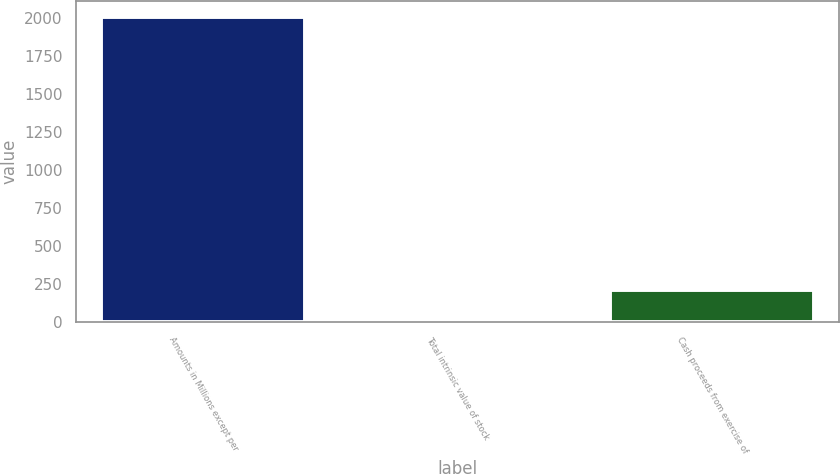Convert chart. <chart><loc_0><loc_0><loc_500><loc_500><bar_chart><fcel>Amounts in Millions except per<fcel>Total intrinsic value of stock<fcel>Cash proceeds from exercise of<nl><fcel>2009<fcel>6<fcel>206.3<nl></chart> 